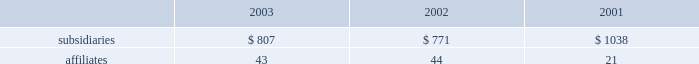Dividends from subsidiaries and affiliates cash dividends received from consolidated subsidiaries and from affiliates accounted for by the equity method were as follows ( in millions ) : .
Guarantees and letters of credit guarantees 2014in connection with certain of its project financing , acquisition , and power purchase agreements , the company has expressly undertaken limited obligations and commitments , most of which will only be effective or will be terminated upon the occurrence of future events .
These obligations and commitments , excluding those collateralized by letter of credit and other obligations discussed below , were limited as of december 31 , 2003 , by the terms of the agreements , to an aggregate of approximately $ 515 million representing 55 agreements with individual exposures ranging from less than $ 1 million up to $ 100 million .
Of this amount , $ 147 million represents credit enhancements for non-recourse debt , and $ 38 million commitments to fund its equity in projects currently under development or in construction .
Letters of credit 2014at december 31 , 2003 , the company had $ 89 million in letters of credit outstanding representing 9 agreements with individual exposures ranging from less than $ 1 million up to $ 36 million , which operate to guarantee performance relating to certain project development and construction activities and subsidiary operations .
The company pays a letter of credit fee ranging from 0.5% ( 0.5 % ) to 5.00% ( 5.00 % ) per annum on the outstanding amounts .
In addition , the company had $ 4 million in surety bonds outstanding at december 31 , 2003. .
What was the average dividend or cash dividends received from consolidated subsidiaries and from affiliates accounted for by the equity method in millions in 2003? 
Computations: (807 / 43)
Answer: 18.76744. Dividends from subsidiaries and affiliates cash dividends received from consolidated subsidiaries and from affiliates accounted for by the equity method were as follows ( in millions ) : .
Guarantees and letters of credit guarantees 2014in connection with certain of its project financing , acquisition , and power purchase agreements , the company has expressly undertaken limited obligations and commitments , most of which will only be effective or will be terminated upon the occurrence of future events .
These obligations and commitments , excluding those collateralized by letter of credit and other obligations discussed below , were limited as of december 31 , 2003 , by the terms of the agreements , to an aggregate of approximately $ 515 million representing 55 agreements with individual exposures ranging from less than $ 1 million up to $ 100 million .
Of this amount , $ 147 million represents credit enhancements for non-recourse debt , and $ 38 million commitments to fund its equity in projects currently under development or in construction .
Letters of credit 2014at december 31 , 2003 , the company had $ 89 million in letters of credit outstanding representing 9 agreements with individual exposures ranging from less than $ 1 million up to $ 36 million , which operate to guarantee performance relating to certain project development and construction activities and subsidiary operations .
The company pays a letter of credit fee ranging from 0.5% ( 0.5 % ) to 5.00% ( 5.00 % ) per annum on the outstanding amounts .
In addition , the company had $ 4 million in surety bonds outstanding at december 31 , 2003. .
At december 31 , 2003 , what was the range of exposures for the outstanding letters of credit? 
Computations: ((36 - 1) * 1000000)
Answer: 35000000.0. 